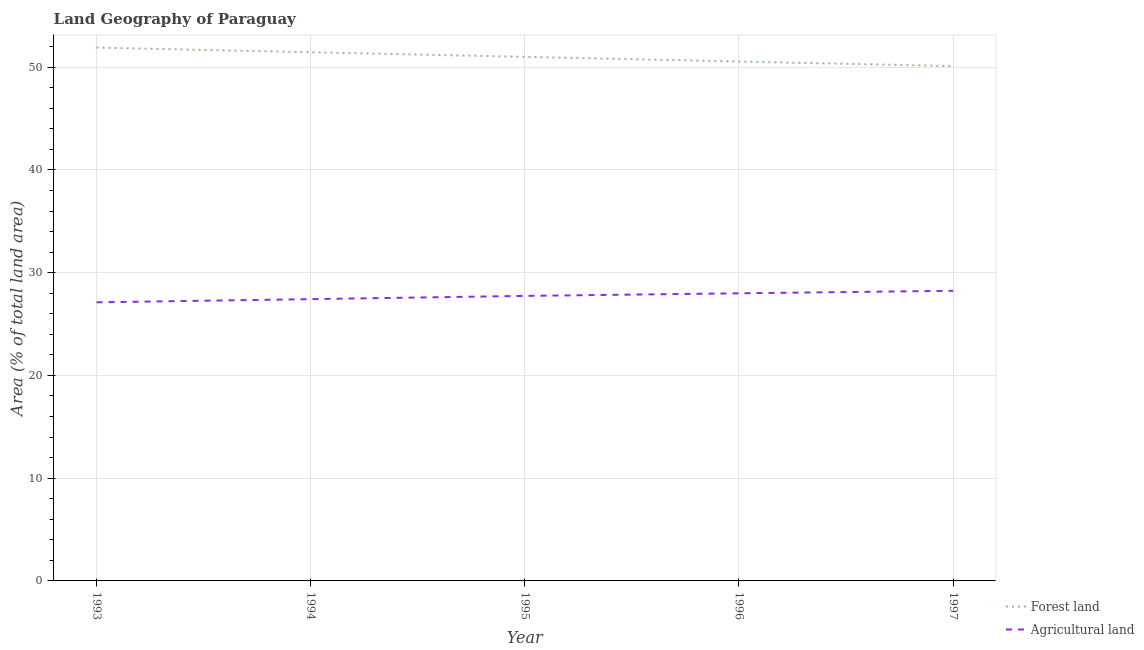How many different coloured lines are there?
Make the answer very short. 2. Does the line corresponding to percentage of land area under agriculture intersect with the line corresponding to percentage of land area under forests?
Make the answer very short. No. What is the percentage of land area under agriculture in 1997?
Your response must be concise. 28.23. Across all years, what is the maximum percentage of land area under forests?
Ensure brevity in your answer.  51.9. Across all years, what is the minimum percentage of land area under agriculture?
Your answer should be compact. 27.11. In which year was the percentage of land area under forests minimum?
Your answer should be compact. 1997. What is the total percentage of land area under forests in the graph?
Your answer should be compact. 255. What is the difference between the percentage of land area under agriculture in 1994 and that in 1997?
Keep it short and to the point. -0.81. What is the difference between the percentage of land area under agriculture in 1995 and the percentage of land area under forests in 1993?
Keep it short and to the point. -24.16. What is the average percentage of land area under agriculture per year?
Your response must be concise. 27.7. In the year 1996, what is the difference between the percentage of land area under agriculture and percentage of land area under forests?
Ensure brevity in your answer.  -22.56. What is the ratio of the percentage of land area under agriculture in 1994 to that in 1995?
Ensure brevity in your answer.  0.99. Is the percentage of land area under forests in 1995 less than that in 1996?
Provide a succinct answer. No. Is the difference between the percentage of land area under forests in 1995 and 1997 greater than the difference between the percentage of land area under agriculture in 1995 and 1997?
Provide a succinct answer. Yes. What is the difference between the highest and the second highest percentage of land area under forests?
Your answer should be very brief. 0.45. What is the difference between the highest and the lowest percentage of land area under forests?
Offer a terse response. 1.8. In how many years, is the percentage of land area under forests greater than the average percentage of land area under forests taken over all years?
Ensure brevity in your answer.  3. Is the sum of the percentage of land area under forests in 1993 and 1997 greater than the maximum percentage of land area under agriculture across all years?
Ensure brevity in your answer.  Yes. Is the percentage of land area under agriculture strictly greater than the percentage of land area under forests over the years?
Your answer should be compact. No. Is the percentage of land area under forests strictly less than the percentage of land area under agriculture over the years?
Provide a succinct answer. No. How many lines are there?
Your answer should be compact. 2. Are the values on the major ticks of Y-axis written in scientific E-notation?
Your answer should be compact. No. Where does the legend appear in the graph?
Give a very brief answer. Bottom right. What is the title of the graph?
Offer a terse response. Land Geography of Paraguay. Does "National Visitors" appear as one of the legend labels in the graph?
Your response must be concise. No. What is the label or title of the Y-axis?
Give a very brief answer. Area (% of total land area). What is the Area (% of total land area) of Forest land in 1993?
Make the answer very short. 51.9. What is the Area (% of total land area) of Agricultural land in 1993?
Provide a succinct answer. 27.11. What is the Area (% of total land area) of Forest land in 1994?
Make the answer very short. 51.45. What is the Area (% of total land area) of Agricultural land in 1994?
Make the answer very short. 27.42. What is the Area (% of total land area) in Forest land in 1995?
Provide a succinct answer. 51. What is the Area (% of total land area) in Agricultural land in 1995?
Your answer should be very brief. 27.74. What is the Area (% of total land area) in Forest land in 1996?
Provide a succinct answer. 50.55. What is the Area (% of total land area) in Agricultural land in 1996?
Provide a short and direct response. 27.99. What is the Area (% of total land area) in Forest land in 1997?
Your answer should be compact. 50.1. What is the Area (% of total land area) of Agricultural land in 1997?
Your response must be concise. 28.23. Across all years, what is the maximum Area (% of total land area) in Forest land?
Your answer should be very brief. 51.9. Across all years, what is the maximum Area (% of total land area) of Agricultural land?
Make the answer very short. 28.23. Across all years, what is the minimum Area (% of total land area) in Forest land?
Provide a succinct answer. 50.1. Across all years, what is the minimum Area (% of total land area) of Agricultural land?
Your answer should be compact. 27.11. What is the total Area (% of total land area) in Forest land in the graph?
Offer a very short reply. 255. What is the total Area (% of total land area) of Agricultural land in the graph?
Offer a terse response. 138.5. What is the difference between the Area (% of total land area) of Forest land in 1993 and that in 1994?
Your answer should be compact. 0.45. What is the difference between the Area (% of total land area) in Agricultural land in 1993 and that in 1994?
Offer a terse response. -0.31. What is the difference between the Area (% of total land area) in Forest land in 1993 and that in 1995?
Your response must be concise. 0.9. What is the difference between the Area (% of total land area) of Agricultural land in 1993 and that in 1995?
Your answer should be very brief. -0.62. What is the difference between the Area (% of total land area) of Forest land in 1993 and that in 1996?
Make the answer very short. 1.35. What is the difference between the Area (% of total land area) in Agricultural land in 1993 and that in 1996?
Provide a succinct answer. -0.88. What is the difference between the Area (% of total land area) in Forest land in 1993 and that in 1997?
Give a very brief answer. 1.8. What is the difference between the Area (% of total land area) in Agricultural land in 1993 and that in 1997?
Make the answer very short. -1.12. What is the difference between the Area (% of total land area) of Forest land in 1994 and that in 1995?
Make the answer very short. 0.45. What is the difference between the Area (% of total land area) in Agricultural land in 1994 and that in 1995?
Provide a succinct answer. -0.31. What is the difference between the Area (% of total land area) of Forest land in 1994 and that in 1996?
Make the answer very short. 0.9. What is the difference between the Area (% of total land area) in Agricultural land in 1994 and that in 1996?
Provide a succinct answer. -0.57. What is the difference between the Area (% of total land area) in Forest land in 1994 and that in 1997?
Provide a succinct answer. 1.35. What is the difference between the Area (% of total land area) of Agricultural land in 1994 and that in 1997?
Give a very brief answer. -0.81. What is the difference between the Area (% of total land area) of Forest land in 1995 and that in 1996?
Your response must be concise. 0.45. What is the difference between the Area (% of total land area) of Agricultural land in 1995 and that in 1996?
Your answer should be very brief. -0.25. What is the difference between the Area (% of total land area) of Forest land in 1995 and that in 1997?
Offer a very short reply. 0.9. What is the difference between the Area (% of total land area) of Agricultural land in 1995 and that in 1997?
Keep it short and to the point. -0.5. What is the difference between the Area (% of total land area) in Forest land in 1996 and that in 1997?
Your answer should be compact. 0.45. What is the difference between the Area (% of total land area) of Agricultural land in 1996 and that in 1997?
Offer a terse response. -0.24. What is the difference between the Area (% of total land area) in Forest land in 1993 and the Area (% of total land area) in Agricultural land in 1994?
Make the answer very short. 24.48. What is the difference between the Area (% of total land area) of Forest land in 1993 and the Area (% of total land area) of Agricultural land in 1995?
Offer a very short reply. 24.16. What is the difference between the Area (% of total land area) of Forest land in 1993 and the Area (% of total land area) of Agricultural land in 1996?
Your answer should be very brief. 23.91. What is the difference between the Area (% of total land area) in Forest land in 1993 and the Area (% of total land area) in Agricultural land in 1997?
Provide a short and direct response. 23.67. What is the difference between the Area (% of total land area) of Forest land in 1994 and the Area (% of total land area) of Agricultural land in 1995?
Offer a terse response. 23.71. What is the difference between the Area (% of total land area) in Forest land in 1994 and the Area (% of total land area) in Agricultural land in 1996?
Make the answer very short. 23.46. What is the difference between the Area (% of total land area) in Forest land in 1994 and the Area (% of total land area) in Agricultural land in 1997?
Make the answer very short. 23.22. What is the difference between the Area (% of total land area) in Forest land in 1995 and the Area (% of total land area) in Agricultural land in 1996?
Ensure brevity in your answer.  23.01. What is the difference between the Area (% of total land area) of Forest land in 1995 and the Area (% of total land area) of Agricultural land in 1997?
Offer a very short reply. 22.77. What is the difference between the Area (% of total land area) in Forest land in 1996 and the Area (% of total land area) in Agricultural land in 1997?
Your answer should be very brief. 22.32. What is the average Area (% of total land area) in Forest land per year?
Your answer should be compact. 51. What is the average Area (% of total land area) in Agricultural land per year?
Make the answer very short. 27.7. In the year 1993, what is the difference between the Area (% of total land area) of Forest land and Area (% of total land area) of Agricultural land?
Your response must be concise. 24.79. In the year 1994, what is the difference between the Area (% of total land area) of Forest land and Area (% of total land area) of Agricultural land?
Your answer should be compact. 24.03. In the year 1995, what is the difference between the Area (% of total land area) in Forest land and Area (% of total land area) in Agricultural land?
Ensure brevity in your answer.  23.26. In the year 1996, what is the difference between the Area (% of total land area) of Forest land and Area (% of total land area) of Agricultural land?
Your answer should be compact. 22.56. In the year 1997, what is the difference between the Area (% of total land area) of Forest land and Area (% of total land area) of Agricultural land?
Your response must be concise. 21.87. What is the ratio of the Area (% of total land area) in Forest land in 1993 to that in 1994?
Offer a very short reply. 1.01. What is the ratio of the Area (% of total land area) in Agricultural land in 1993 to that in 1994?
Provide a succinct answer. 0.99. What is the ratio of the Area (% of total land area) of Forest land in 1993 to that in 1995?
Your answer should be very brief. 1.02. What is the ratio of the Area (% of total land area) of Agricultural land in 1993 to that in 1995?
Your answer should be compact. 0.98. What is the ratio of the Area (% of total land area) in Forest land in 1993 to that in 1996?
Ensure brevity in your answer.  1.03. What is the ratio of the Area (% of total land area) of Agricultural land in 1993 to that in 1996?
Keep it short and to the point. 0.97. What is the ratio of the Area (% of total land area) in Forest land in 1993 to that in 1997?
Your answer should be compact. 1.04. What is the ratio of the Area (% of total land area) of Agricultural land in 1993 to that in 1997?
Keep it short and to the point. 0.96. What is the ratio of the Area (% of total land area) in Forest land in 1994 to that in 1995?
Your answer should be compact. 1.01. What is the ratio of the Area (% of total land area) of Agricultural land in 1994 to that in 1995?
Your answer should be very brief. 0.99. What is the ratio of the Area (% of total land area) of Forest land in 1994 to that in 1996?
Make the answer very short. 1.02. What is the ratio of the Area (% of total land area) in Agricultural land in 1994 to that in 1996?
Offer a terse response. 0.98. What is the ratio of the Area (% of total land area) in Forest land in 1994 to that in 1997?
Offer a very short reply. 1.03. What is the ratio of the Area (% of total land area) of Agricultural land in 1994 to that in 1997?
Offer a very short reply. 0.97. What is the ratio of the Area (% of total land area) of Forest land in 1995 to that in 1996?
Your answer should be compact. 1.01. What is the ratio of the Area (% of total land area) of Agricultural land in 1995 to that in 1996?
Ensure brevity in your answer.  0.99. What is the ratio of the Area (% of total land area) in Forest land in 1995 to that in 1997?
Make the answer very short. 1.02. What is the ratio of the Area (% of total land area) of Agricultural land in 1995 to that in 1997?
Offer a very short reply. 0.98. What is the difference between the highest and the second highest Area (% of total land area) in Forest land?
Keep it short and to the point. 0.45. What is the difference between the highest and the second highest Area (% of total land area) of Agricultural land?
Provide a short and direct response. 0.24. What is the difference between the highest and the lowest Area (% of total land area) of Forest land?
Offer a terse response. 1.8. What is the difference between the highest and the lowest Area (% of total land area) of Agricultural land?
Provide a succinct answer. 1.12. 